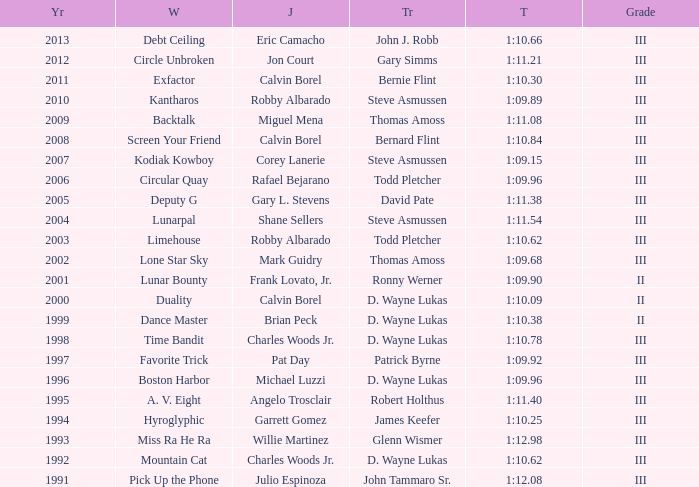Which trainer won the hyroglyphic in a year that was before 2010? James Keefer. 